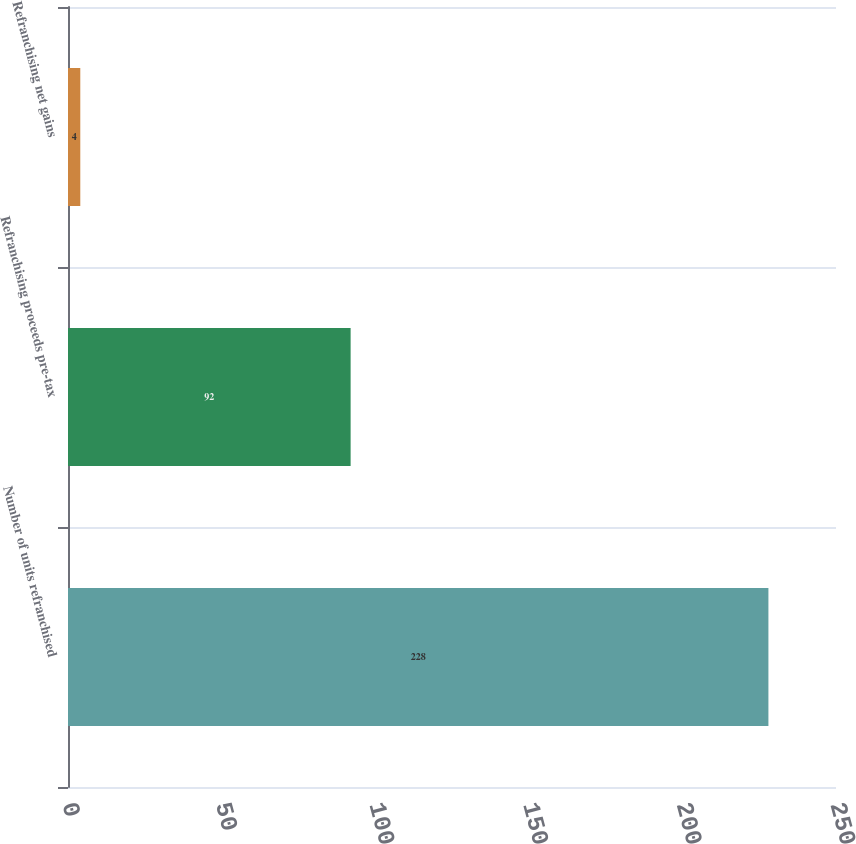Convert chart to OTSL. <chart><loc_0><loc_0><loc_500><loc_500><bar_chart><fcel>Number of units refranchised<fcel>Refranchising proceeds pre-tax<fcel>Refranchising net gains<nl><fcel>228<fcel>92<fcel>4<nl></chart> 